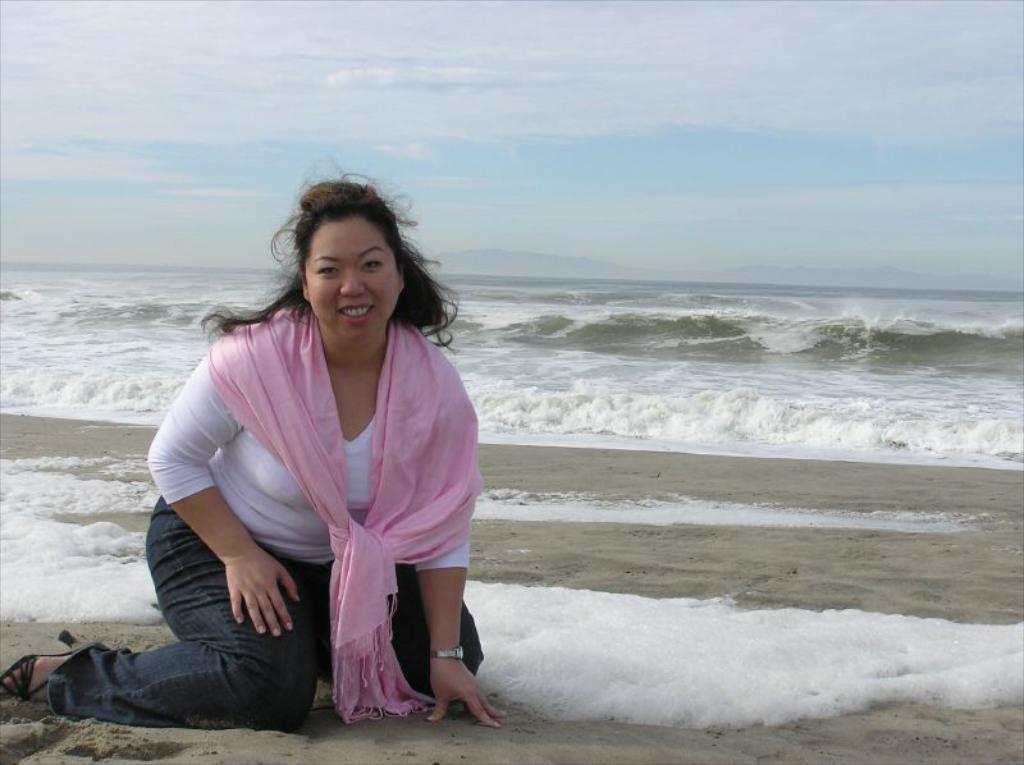Please provide a concise description of this image. In this image there is a woman in the middle who is kneeling down on the ground. Behind her there are waves. At the top there is the sky. She is wearing the pink color scarf. 